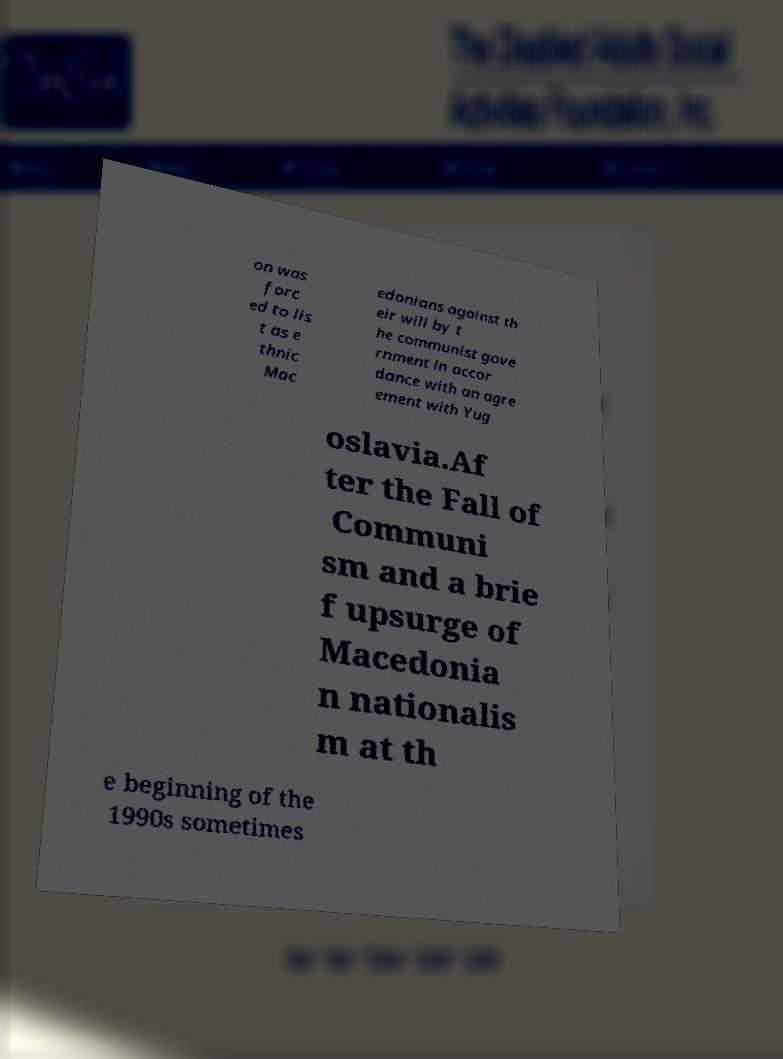Could you assist in decoding the text presented in this image and type it out clearly? on was forc ed to lis t as e thnic Mac edonians against th eir will by t he communist gove rnment in accor dance with an agre ement with Yug oslavia.Af ter the Fall of Communi sm and a brie f upsurge of Macedonia n nationalis m at th e beginning of the 1990s sometimes 